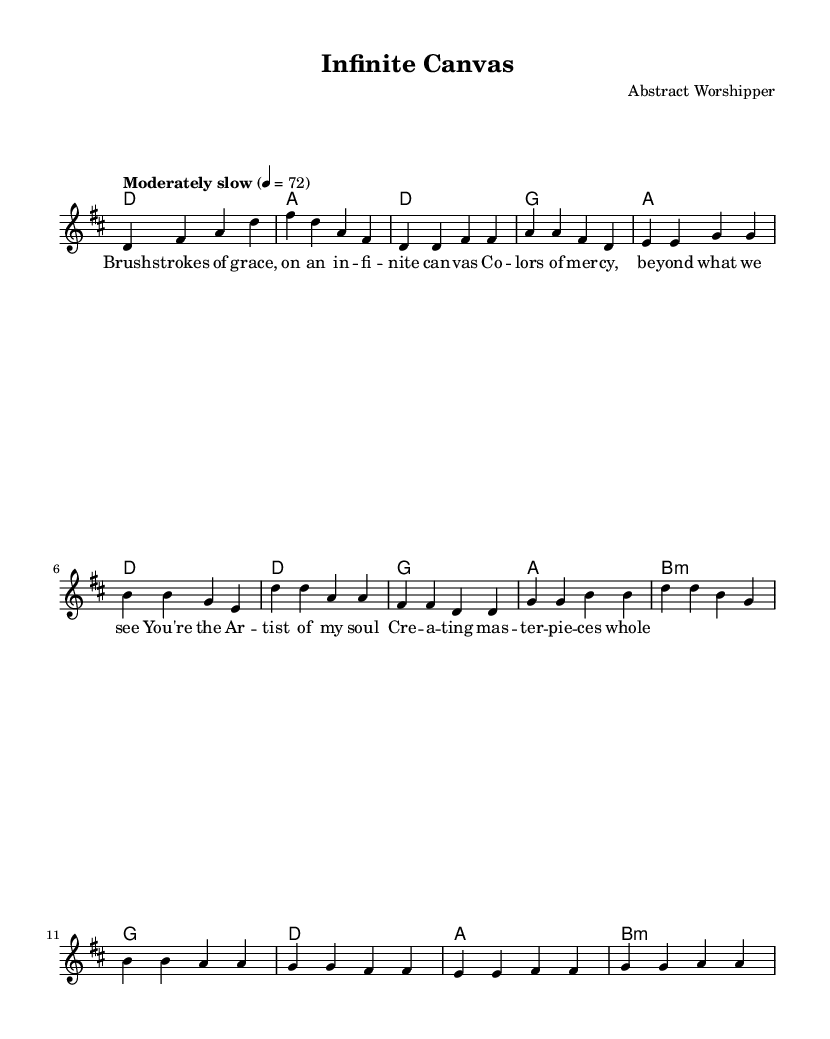What is the key signature of this music? The key signature displayed in the music is D major, which has two sharps (F# and C#). This can be seen at the beginning of the sheet music where the key signature is indicated.
Answer: D major What is the time signature of this music? The time signature shown in the music is 4/4, which means there are four beats in each measure and the quarter note gets one beat. This information is indicated near the beginning of the sheet music.
Answer: 4/4 What is the tempo marking of this piece? The tempo marking in the music states "Moderately slow" with a metronome indication of 72 beats per minute, giving a clear instruction on the performance speed. The tempo marking is located at the beginning where the global parameters are specified.
Answer: Moderately slow How many measures are in the verse section? The verse section consists of 4 measures, which can be counted from the corresponding part in the sheet music where the melody and harmonies for the verse are defined. Each grouping of notes separated by bar lines delineates the measures.
Answer: 4 measures What is the primary imagery expressed in the lyrics? The lyrics of the verse describe an artistic process, using phrases like "Brush strokes of grace" and "Colors of mercy," which convey abstract and creative imagery related to spirituality and worship. This interpretation can be obtained by analyzing the lyrical content of the verse.
Answer: Artistic process What is the harmonic progression in the chorus? The harmonic progression in the chorus features a sequence of chords that follow a D, G, A, and B minor structure, which creates an uplifting feeling appropriate for worship music. This can be identified through the chord names corresponding to the melody in the chorus section.
Answer: D, G, A, B minor What role does the bridge play in the overall structure of the song? The bridge serves as a contrasting section that intensifies the emotional expression and thematic development of the song, typically preparing the listener for the return to the chorus. This connects the lyrics and musical ideas presented in the bridge to the overall narrative of worship and reflection.
Answer: Contrast and transition 